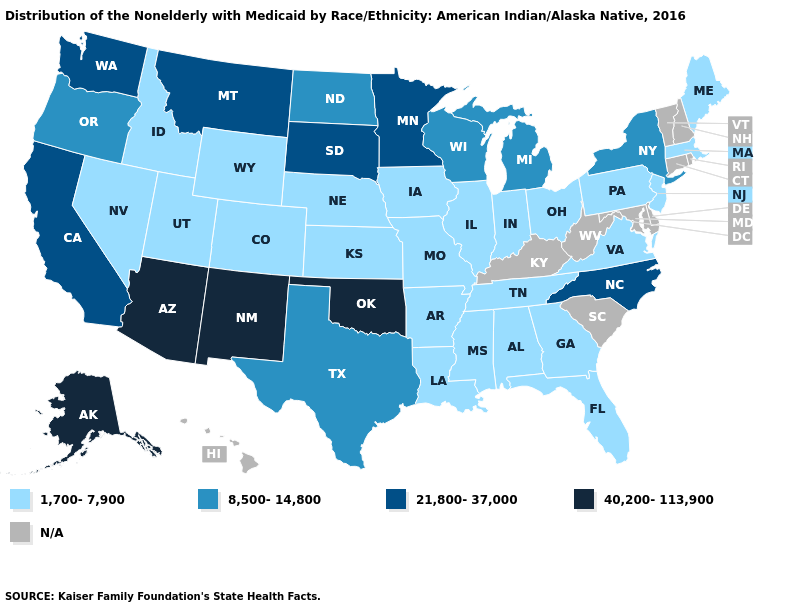Does the first symbol in the legend represent the smallest category?
Be succinct. Yes. How many symbols are there in the legend?
Concise answer only. 5. What is the value of Arkansas?
Short answer required. 1,700-7,900. What is the value of Colorado?
Be succinct. 1,700-7,900. Does Missouri have the lowest value in the USA?
Write a very short answer. Yes. How many symbols are there in the legend?
Answer briefly. 5. What is the value of Nevada?
Be succinct. 1,700-7,900. Among the states that border Michigan , which have the lowest value?
Concise answer only. Indiana, Ohio. Which states have the lowest value in the USA?
Keep it brief. Alabama, Arkansas, Colorado, Florida, Georgia, Idaho, Illinois, Indiana, Iowa, Kansas, Louisiana, Maine, Massachusetts, Mississippi, Missouri, Nebraska, Nevada, New Jersey, Ohio, Pennsylvania, Tennessee, Utah, Virginia, Wyoming. What is the highest value in states that border Texas?
Short answer required. 40,200-113,900. Among the states that border Louisiana , does Arkansas have the lowest value?
Concise answer only. Yes. Name the states that have a value in the range N/A?
Answer briefly. Connecticut, Delaware, Hawaii, Kentucky, Maryland, New Hampshire, Rhode Island, South Carolina, Vermont, West Virginia. Name the states that have a value in the range 40,200-113,900?
Short answer required. Alaska, Arizona, New Mexico, Oklahoma. 